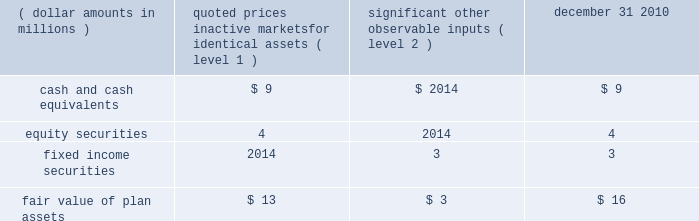1 2 4 n o t e s effective january 1 , 2011 , all u.s .
Employees , including u.s .
Legacy bgi employees , will participate in the brsp .
All plan assets in the two legacy bgi plans , including the 401k plan and retirement plan ( see below ) , were merged into the brsp on january 1 , 2011 .
Under the combined brsp , employee contributions of up to 8% ( 8 % ) of eligible compensation , as defined by the plan and subject to irc limitations , will be matched by the company at 50% ( 50 % ) .
In addition , the company will continue to make an annual retirement contribution to eligible participants equal to 3-5% ( 3-5 % ) of eligible compensation .
Blackrock institutional trust company 401 ( k ) savings plan ( formerly the bgi 401 ( k ) savings plan ) the company assumed a 401 ( k ) plan ( the 201cbgi plan 201d ) covering employees of former bgi as a result of the bgi transaction .
As part of the bgi plan , employee contributions for participants with at least one year of service were matched at 200% ( 200 % ) of participants 2019 pre-tax contributions up to 2% ( 2 % ) of base salary and overtime , and matched 100% ( 100 % ) of the next 2% ( 2 % ) of base salary and overtime , as defined by the plan and subject to irc limitations .
The maximum matching contribution a participant would have received is an amount equal to 6% ( 6 % ) of base salary up to the irc limitations .
The bgi plan expense was $ 12 million for the year ended december 31 , 2010 and immaterial to the company 2019s consolidated financial statements for the year ended december 31 , 2009 .
Effective january 1 , 2011 , the net assets of this plan merged into the brsp .
Blackrock institutional trust company retirement plan ( formerly the bgi retirement plan ) the company assumed a defined contribution money purchase pension plan ( 201cbgi retirement plan 201d ) as a result of the bgi transaction .
All salaried employees of former bgi and its participating affiliates who were u.s .
Residents on the u.s .
Payroll were eligible to participate .
For participants earning less than $ 100000 in base salary , the company contributed 6% ( 6 % ) of a participant 2019s total compensation ( base salary , overtime and performance bonus ) up to $ 100000 .
For participants earning $ 100000 or more in base salary , the company contributed 6% ( 6 % ) of a participant 2019s base salary and overtime up to the irc limita- tion of $ 245000 in 2010 .
These contributions were 25% ( 25 % ) vested once the participant has completed two years of service and then vested at a rate of 25% ( 25 % ) for each additional year of service completed .
Employees with five or more years of service under the retirement plan were 100% ( 100 % ) vested in their entire balance .
The retirement plan expense was $ 13 million for the year ended december 31 , 2010 and immaterial to the company 2019s consolidated financial statements for the year ended december 31 , 2009 .
Effective january 1 , 2011 , the net assets of this plan merged into the brsp .
Blackrock group personal pension plan blackrock investment management ( uk ) limited ( 201cbim 201d ) , a wholly-owned subsidiary of the company , contributes to the blackrock group personal pension plan , a defined contribution plan for all employees of bim .
Bim contributes between 6% ( 6 % ) and 15% ( 15 % ) of each employee 2019s eligible compensation .
The expense for this plan was $ 22 million , $ 13 million and $ 16 million for the years ended december 31 , 2010 , 2009 and 2008 , respectively .
Defined benefit plans in 2009 , prior to the bgi transaction , the company had several defined benefit pension plans in japan , germany , luxembourg and jersey .
All accrued benefits under these defined benefit plans are currently frozen and the plans are closed to new participants .
In 2008 , the defined benefit pension values in luxembourg were transferred into a new defined contribution plan for such employees , removing future liabilities .
Participant benefits under the plans will not change with salary increases or additional years of service .
Through the bgi transaction , the company assumed defined benefit pension plans in japan and germany which are closed to new participants .
During 2010 , these plans merged into the legacy blackrock plans in japan ( the 201cjapan plan 201d ) and germany .
At december 31 , 2010 and 2009 , the plan assets for these plans were approximately $ 19 million and $ 10 million , respectively , and the unfunded obligations were less than $ 6 million and $ 3 million , respectively , which were recorded in accrued compensation and benefits on the consolidated statements of financial condition .
Benefit payments for the next five years and in aggregate for the five years thereafter are not expected to be material .
Defined benefit plan assets for the japan plan of approximately $ 16 million are invested using a total return investment approach whereby a mix of equity securities , debt securities and other investments are used to preserve asset values , diversify risk and achieve the target investment return benchmark .
Investment strategies and asset allocations are based on consideration of plan liabilities and the funded status of the plan .
Investment performance and asset allocation are measured and monitored on an ongoing basis .
The current target allocations for the plan assets are 45-50% ( 45-50 % ) for u.s .
And international equity securities , 50-55% ( 50-55 % ) for u.s .
And international fixed income securities and 0-5% ( 0-5 % ) for cash and cash equivalents .
The table below provides the fair value of the defined benefit japan plan assets at december 31 , 2010 by asset category .
The table also identifies the level of inputs used to determine the fair value of assets in each category .
Quoted prices significant in active other markets for observable identical assets inputs december 31 , ( dollar amounts in millions ) ( level 1 ) ( level 2 ) 2010 .
The assets and unfunded obligation for the defined benefit pension plan in germany and jersey were immaterial to the company 2019s consolidated financial statements at december 31 , 2010 .
Post-retirement benefit plans prior to the bgi transaction , the company had requirements to deliver post-retirement medical benefits to a closed population based in the united kingdom and through the bgi transaction , the company assumed a post-retirement benefit plan to a closed population of former bgi employees in the united kingdom .
For the years ended december 31 , 2010 , 2009 and 2008 , expenses and unfunded obligations for these benefits were immaterial to the company 2019s consolidated financial statements .
In addition , through the bgi transaction , the company assumed a requirement to deliver post-retirement medical benefits to a .
What is the percentage change in expenses related to personal pension plan from 2009 to 2010? 
Computations: ((22 - 13) / 13)
Answer: 0.69231. 